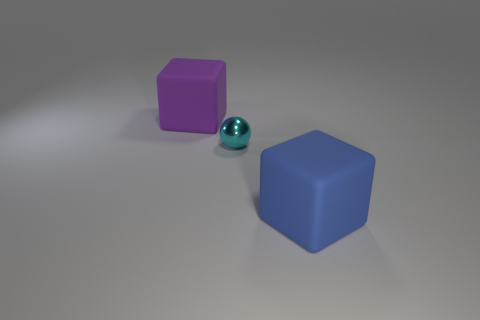Subtract all balls. How many objects are left? 2 Subtract 1 cubes. How many cubes are left? 1 Subtract all purple spheres. Subtract all yellow blocks. How many spheres are left? 1 Subtract all yellow balls. How many blue blocks are left? 1 Subtract all small balls. Subtract all gray matte cylinders. How many objects are left? 2 Add 1 large purple rubber cubes. How many large purple rubber cubes are left? 2 Add 2 cyan objects. How many cyan objects exist? 3 Add 3 large blue rubber things. How many objects exist? 6 Subtract all purple blocks. How many blocks are left? 1 Subtract 0 gray spheres. How many objects are left? 3 